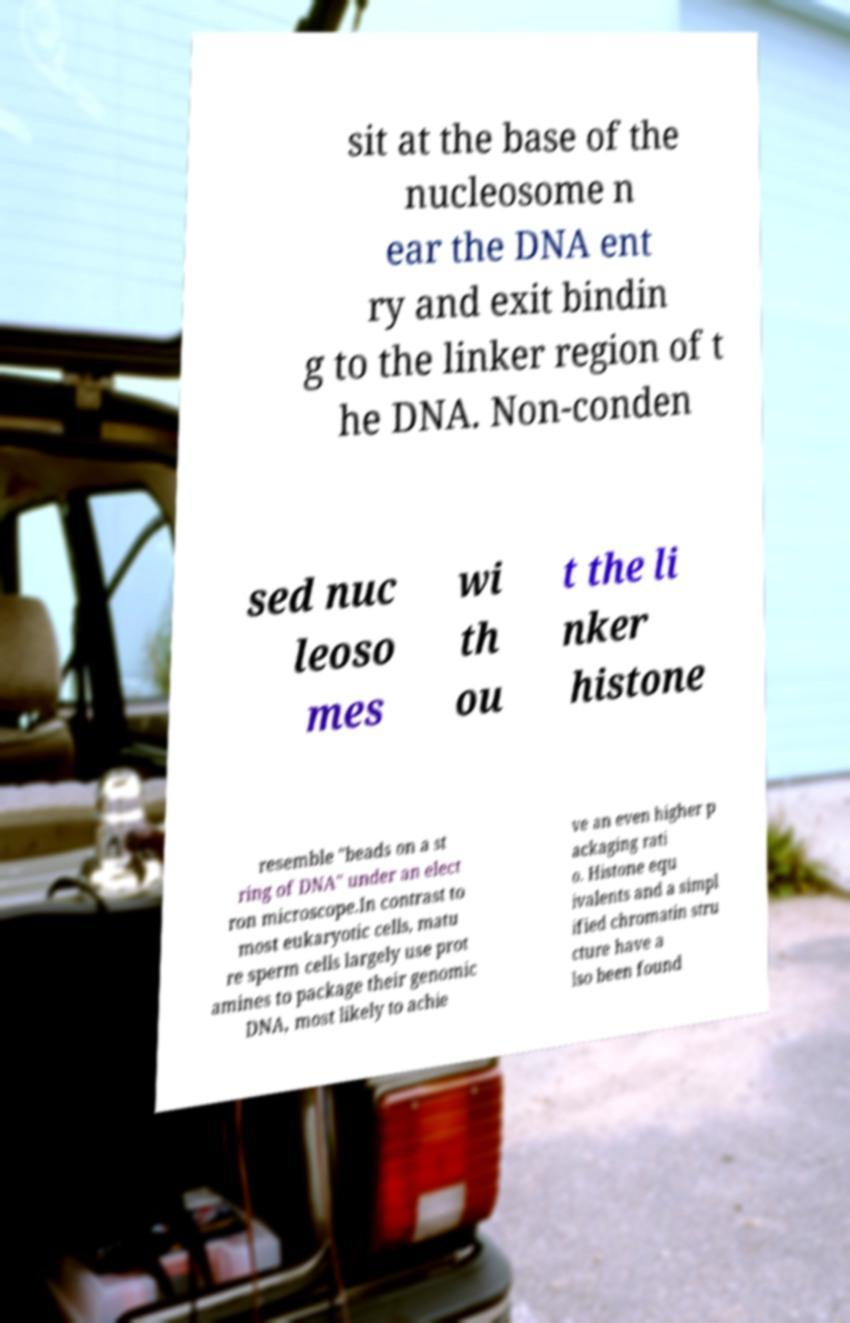What messages or text are displayed in this image? I need them in a readable, typed format. sit at the base of the nucleosome n ear the DNA ent ry and exit bindin g to the linker region of t he DNA. Non-conden sed nuc leoso mes wi th ou t the li nker histone resemble "beads on a st ring of DNA" under an elect ron microscope.In contrast to most eukaryotic cells, matu re sperm cells largely use prot amines to package their genomic DNA, most likely to achie ve an even higher p ackaging rati o. Histone equ ivalents and a simpl ified chromatin stru cture have a lso been found 